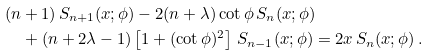<formula> <loc_0><loc_0><loc_500><loc_500>& ( n + 1 ) \, S _ { n + 1 } ( x ; \phi ) - 2 ( n + \lambda ) \cot \phi \, S _ { n } ( x ; \phi ) \\ & \quad + ( n + 2 \lambda - 1 ) \left [ 1 + ( \cot \phi ) ^ { 2 } \right ] \, S _ { n - 1 } ( x ; \phi ) = 2 x \, S _ { n } ( x ; \phi ) \, .</formula> 